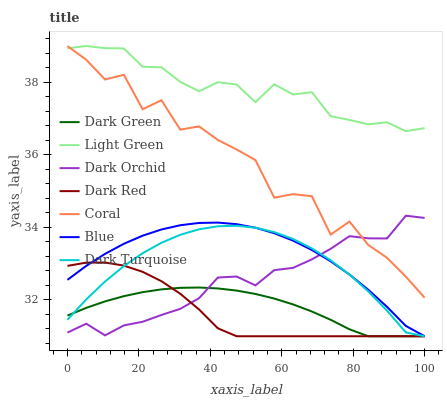Does Coral have the minimum area under the curve?
Answer yes or no. No. Does Coral have the maximum area under the curve?
Answer yes or no. No. Is Dark Red the smoothest?
Answer yes or no. No. Is Dark Red the roughest?
Answer yes or no. No. Does Coral have the lowest value?
Answer yes or no. No. Does Dark Red have the highest value?
Answer yes or no. No. Is Dark Turquoise less than Coral?
Answer yes or no. Yes. Is Light Green greater than Dark Red?
Answer yes or no. Yes. Does Dark Turquoise intersect Coral?
Answer yes or no. No. 